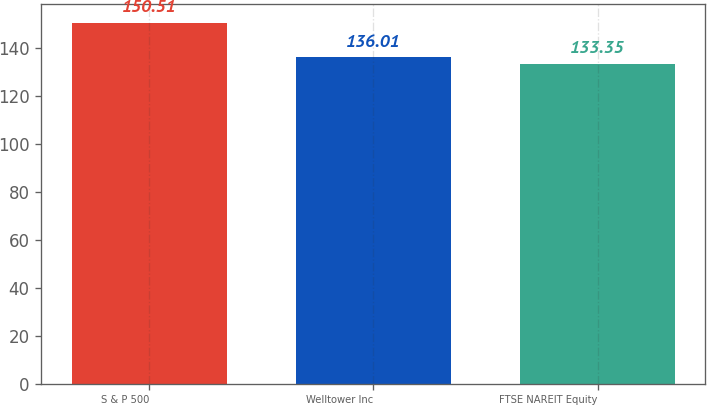Convert chart to OTSL. <chart><loc_0><loc_0><loc_500><loc_500><bar_chart><fcel>S & P 500<fcel>Welltower Inc<fcel>FTSE NAREIT Equity<nl><fcel>150.51<fcel>136.01<fcel>133.35<nl></chart> 